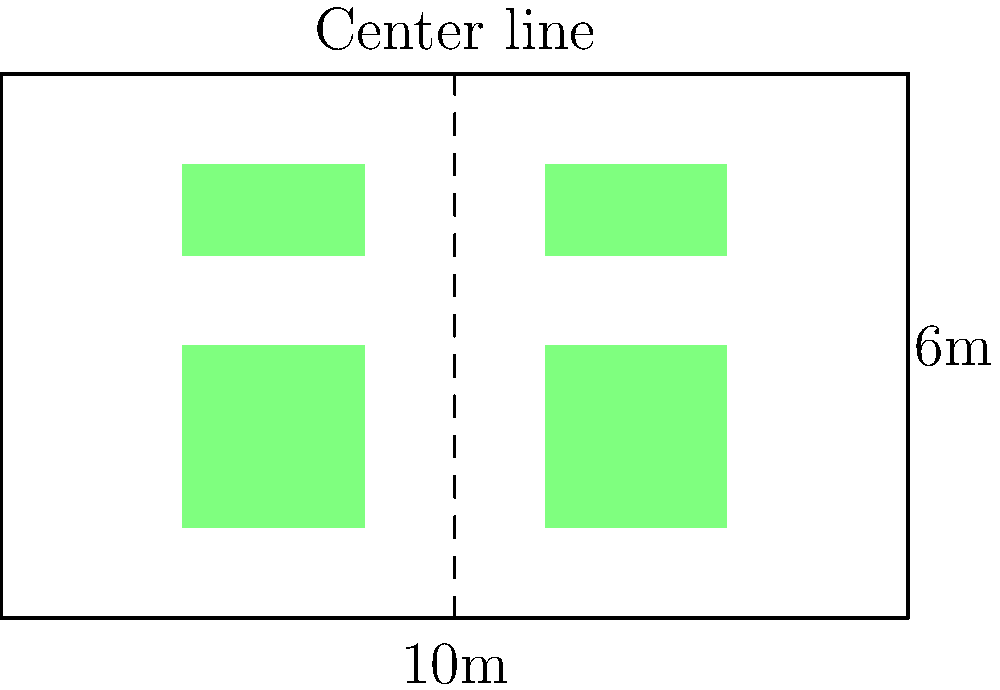In the excavated Renaissance garden parterre shown above, you've uncovered four plant bed outlines. The parterre measures 10m wide by 6m long. Assuming the design follows perfect symmetry, what is the width of each plant bed in meters? To solve this problem, we'll follow these steps:

1. Recognize the symmetry: The parterre is divided by a center line, creating two identical halves.

2. Focus on one half: We only need to examine one side to determine the bed width.

3. Analyze the layout: On each side, there are two beds arranged vertically.

4. Calculate the available space:
   - The total width of the parterre is 10m.
   - Each half is therefore 5m wide.

5. Determine the gaps:
   - There's a gap between the edge and the bed.
   - There's also a gap between the bed and the center line.
   - These gaps appear to be equal and are necessary for maintaining symmetry.

6. Calculate the bed width:
   - Let x be the width of each gap.
   - The bed width will be 5 - 2x (total half-width minus two gaps).
   - From the diagram, we can see that the bed occupies about 2/5 of the half-width.
   - Therefore, 5 - 2x = 2/5 * 5 = 2

7. Solve the equation:
   $$5 - 2x = 2$$
   $$-2x = -3$$
   $$x = 1.5$$

8. Verify:
   - Each gap is 1.5m
   - Bed width = 5 - (2 * 1.5) = 2m

Therefore, the width of each plant bed is 2 meters.
Answer: 2m 